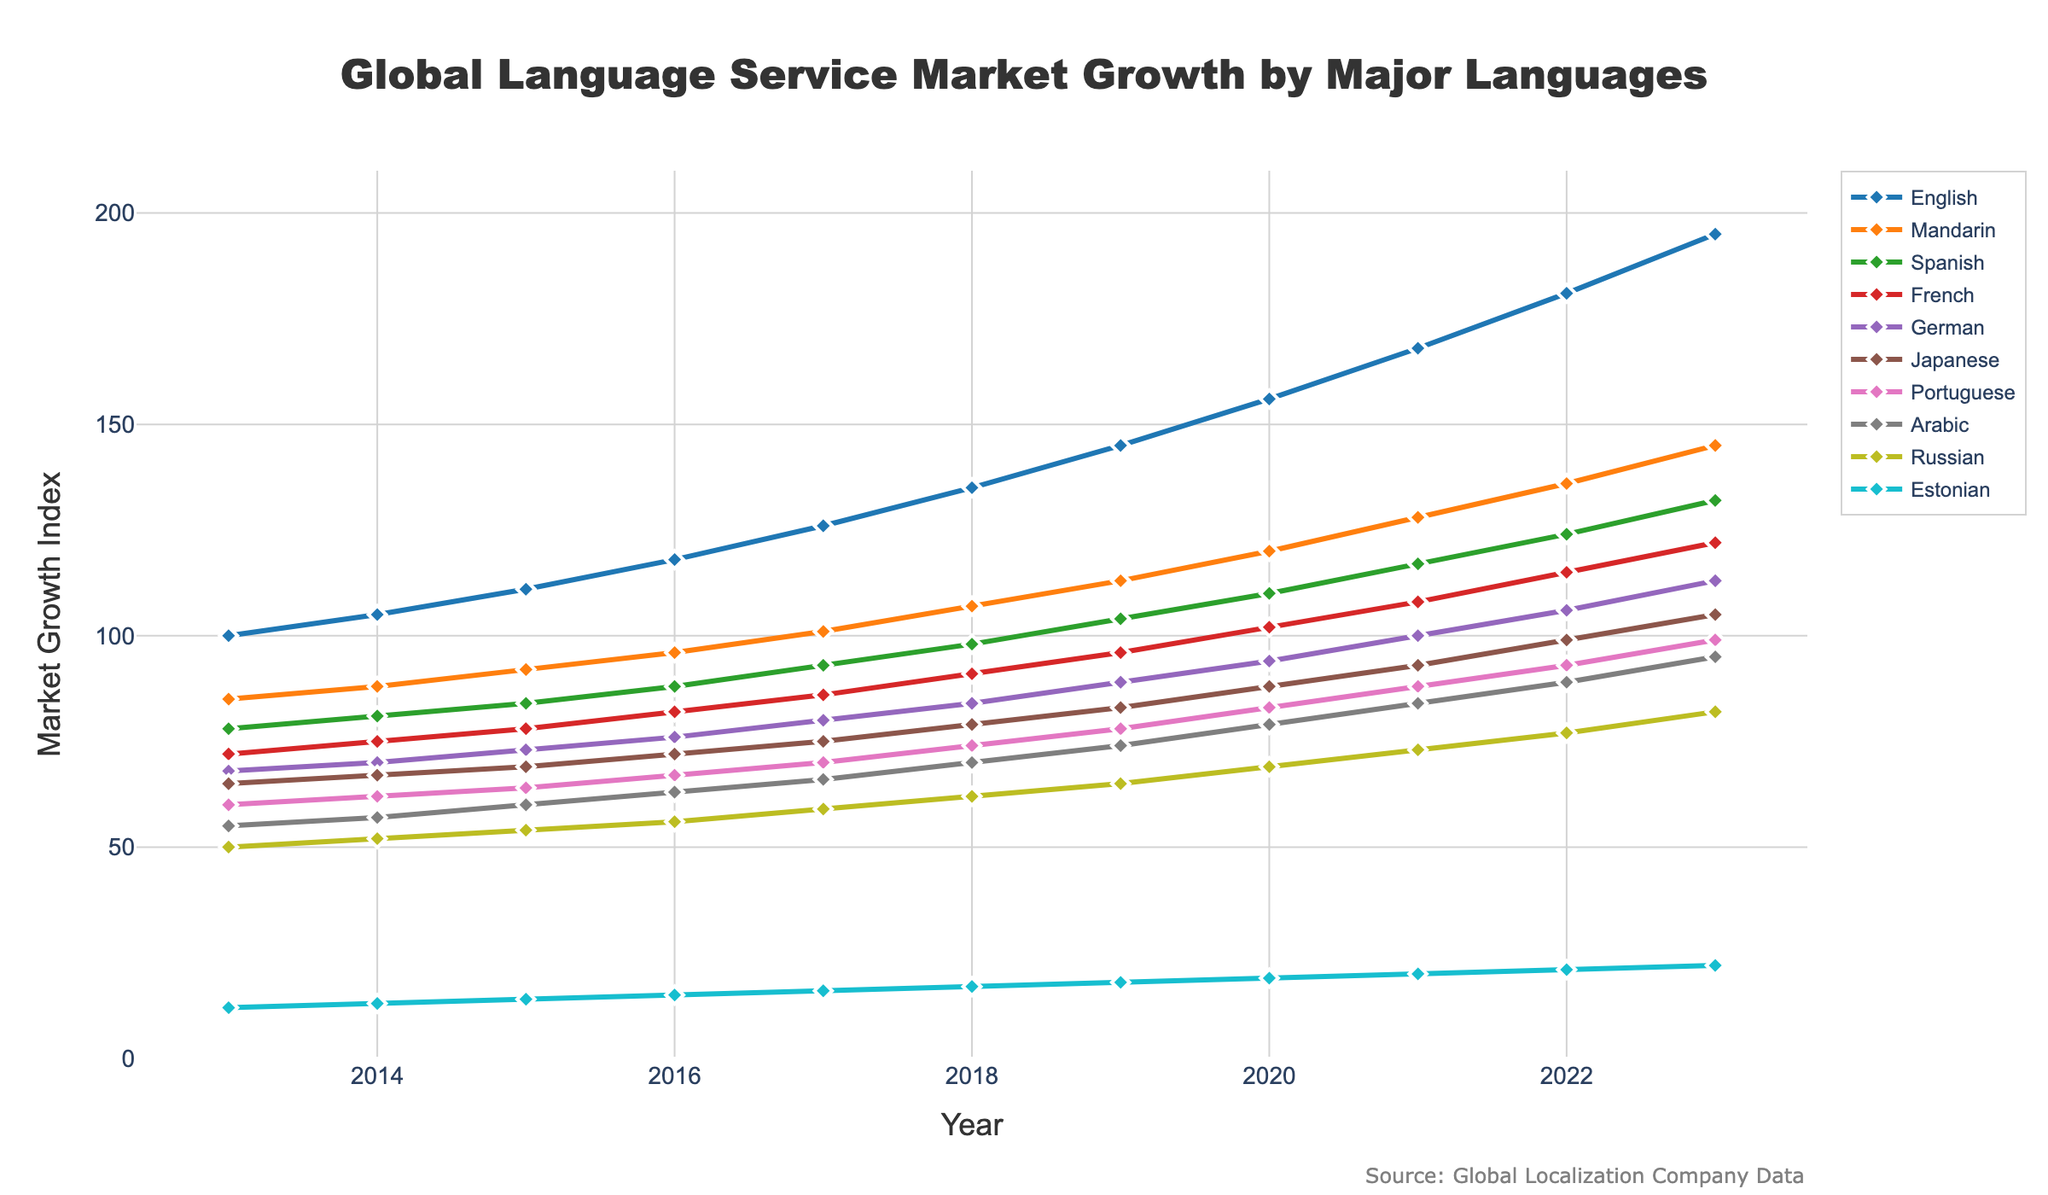What was the market growth index for German in 2017? Look at the growth index for the German line at the year 2017 on the X-axis.
Answer: 80 Which language had the highest market growth index in 2023? Observe the lines and identify the one that reaches the highest point on the Y-axis for the year 2023.
Answer: English What can be said about the trend of the Estonian language from 2013 to 2023? Notice the slope of the Estonian line, whether it is generally increasing, decreasing, or remaining constant over the years.
Answer: Increasing How much did the market growth index for Japanese change from 2013 to 2022? Subtract the value for Japanese in 2013 from the value in 2022 (105 - 65).
Answer: 40 Between which years did the market growth index for French experience the highest single-year increase? Compare the year-over-year increments for French on the Y-axis.
Answer: 2019 and 2020 What was the average market growth index for Mandarin over the decade? Sum the annual values for Mandarin and divide by the number of years (2013-2023). (85+88+92+96+101+107+113+120+128+136+145) / 11
Answer: 112 Compare the market growth index for Portuguese in 2020 and Arabic in 2023. Which is higher? Look at the values for Portuguese in 2020 and Arabic in 2023 and compare them.
Answer: Arabic in 2023 is higher By how much did the market growth index for Russian increase from 2018 to 2021? Subtract the value in 2018 from the value in 2021 (73 - 62).
Answer: 11 Which language consistently had the lowest market growth index throughout the years? Identify the line that remains at the lowest point on the Y-axis consistently from 2013 to 2023.
Answer: Estonian Estimate the difference between the market growth index of English and Mandarin in 2023. Subtract the value for Mandarin from the value for English in 2023 (195 - 145).
Answer: 50 